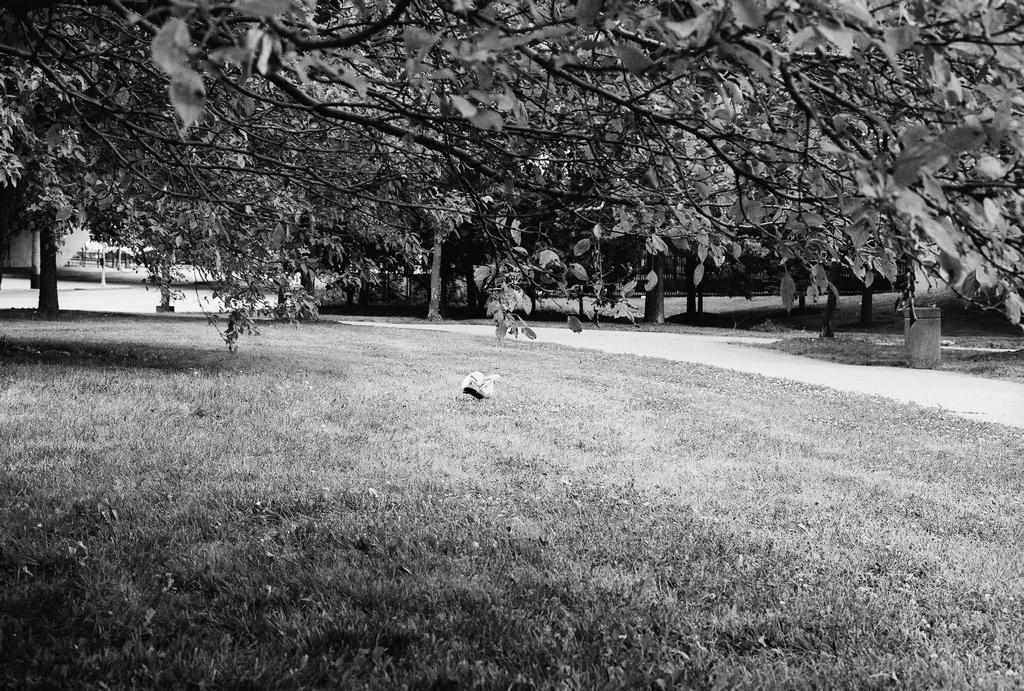What type of vegetation is present in the image? There are many trees, plants, and grass in the image. Can you describe the landscape in the image? The image features a landscape with trees, plants, and grass. Are there any structures visible on the left side of the image? There might be a pole and other structures on the left side of the image. How many boys are playing with the ladybug in the image? There are no boys or ladybugs present in the image. 